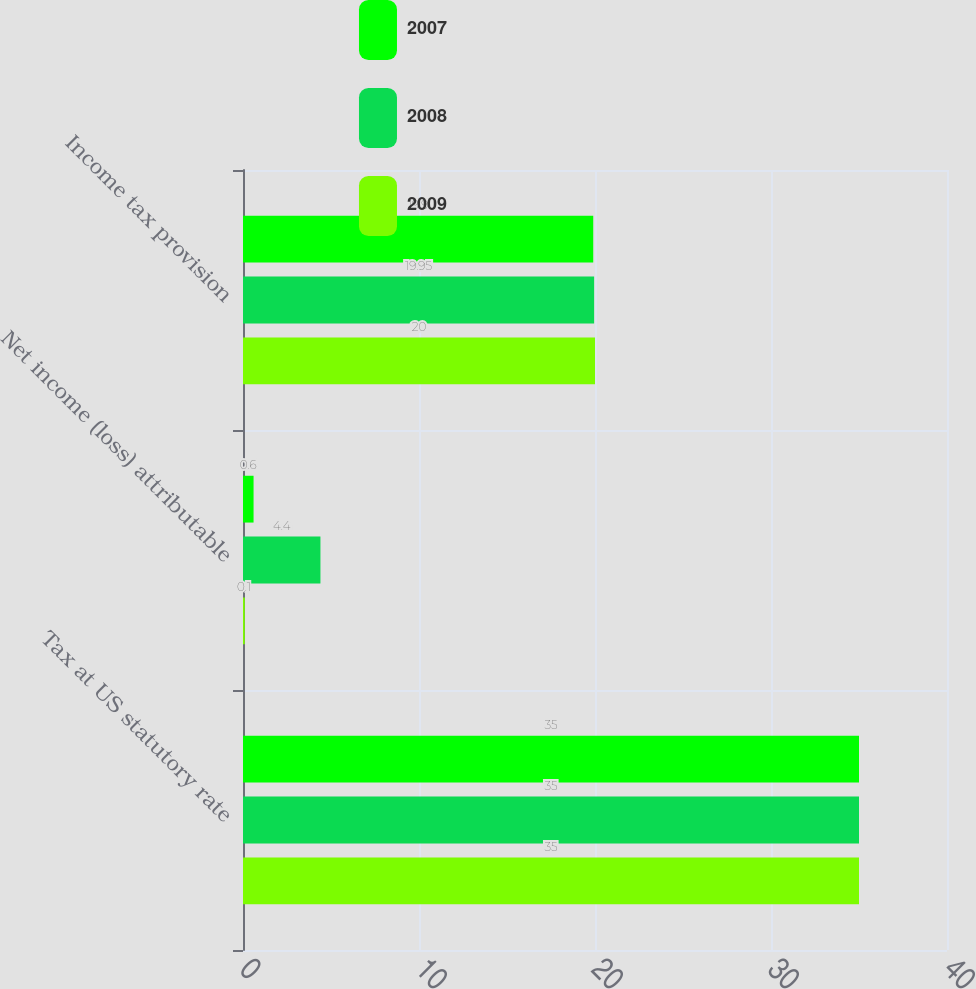Convert chart. <chart><loc_0><loc_0><loc_500><loc_500><stacked_bar_chart><ecel><fcel>Tax at US statutory rate<fcel>Net income (loss) attributable<fcel>Income tax provision<nl><fcel>2007<fcel>35<fcel>0.6<fcel>19.9<nl><fcel>2008<fcel>35<fcel>4.4<fcel>19.95<nl><fcel>2009<fcel>35<fcel>0.1<fcel>20<nl></chart> 